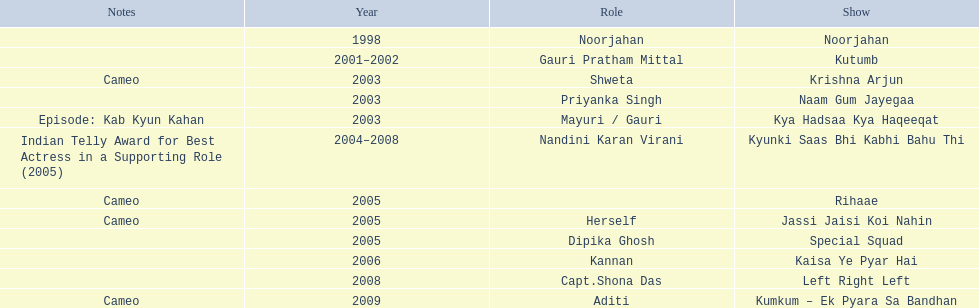What are all of the shows? Noorjahan, Kutumb, Krishna Arjun, Naam Gum Jayegaa, Kya Hadsaa Kya Haqeeqat, Kyunki Saas Bhi Kabhi Bahu Thi, Rihaae, Jassi Jaisi Koi Nahin, Special Squad, Kaisa Ye Pyar Hai, Left Right Left, Kumkum – Ek Pyara Sa Bandhan. When did they premiere? 1998, 2001–2002, 2003, 2003, 2003, 2004–2008, 2005, 2005, 2005, 2006, 2008, 2009. What notes are there for the shows from 2005? Cameo, Cameo. Along with rihaee, what is the other show gauri had a cameo role in? Jassi Jaisi Koi Nahin. 